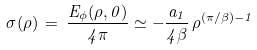<formula> <loc_0><loc_0><loc_500><loc_500>\sigma ( \rho ) \, = \, \frac { E _ { \phi } ( \rho , 0 ) } { 4 \pi } \simeq - \frac { a _ { 1 } } { 4 \beta } \, \rho ^ { ( \pi / \beta ) - 1 }</formula> 